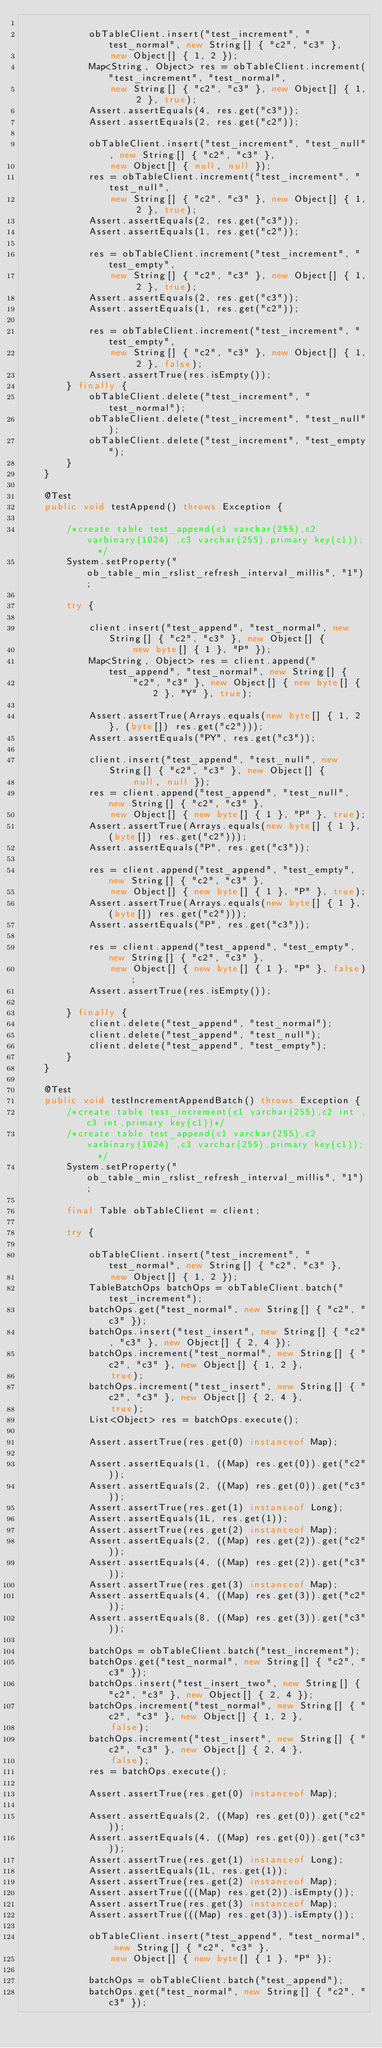Convert code to text. <code><loc_0><loc_0><loc_500><loc_500><_Java_>
            obTableClient.insert("test_increment", "test_normal", new String[] { "c2", "c3" },
                new Object[] { 1, 2 });
            Map<String, Object> res = obTableClient.increment("test_increment", "test_normal",
                new String[] { "c2", "c3" }, new Object[] { 1, 2 }, true);
            Assert.assertEquals(4, res.get("c3"));
            Assert.assertEquals(2, res.get("c2"));

            obTableClient.insert("test_increment", "test_null", new String[] { "c2", "c3" },
                new Object[] { null, null });
            res = obTableClient.increment("test_increment", "test_null",
                new String[] { "c2", "c3" }, new Object[] { 1, 2 }, true);
            Assert.assertEquals(2, res.get("c3"));
            Assert.assertEquals(1, res.get("c2"));

            res = obTableClient.increment("test_increment", "test_empty",
                new String[] { "c2", "c3" }, new Object[] { 1, 2 }, true);
            Assert.assertEquals(2, res.get("c3"));
            Assert.assertEquals(1, res.get("c2"));

            res = obTableClient.increment("test_increment", "test_empty",
                new String[] { "c2", "c3" }, new Object[] { 1, 2 }, false);
            Assert.assertTrue(res.isEmpty());
        } finally {
            obTableClient.delete("test_increment", "test_normal");
            obTableClient.delete("test_increment", "test_null");
            obTableClient.delete("test_increment", "test_empty");
        }
    }

    @Test
    public void testAppend() throws Exception {

        /*create table test_append(c1 varchar(255),c2 varbinary(1024) ,c3 varchar(255),primary key(c1));  */
        System.setProperty("ob_table_min_rslist_refresh_interval_millis", "1");

        try {

            client.insert("test_append", "test_normal", new String[] { "c2", "c3" }, new Object[] {
                    new byte[] { 1 }, "P" });
            Map<String, Object> res = client.append("test_append", "test_normal", new String[] {
                    "c2", "c3" }, new Object[] { new byte[] { 2 }, "Y" }, true);

            Assert.assertTrue(Arrays.equals(new byte[] { 1, 2 }, (byte[]) res.get("c2")));
            Assert.assertEquals("PY", res.get("c3"));

            client.insert("test_append", "test_null", new String[] { "c2", "c3" }, new Object[] {
                    null, null });
            res = client.append("test_append", "test_null", new String[] { "c2", "c3" },
                new Object[] { new byte[] { 1 }, "P" }, true);
            Assert.assertTrue(Arrays.equals(new byte[] { 1 }, (byte[]) res.get("c2")));
            Assert.assertEquals("P", res.get("c3"));

            res = client.append("test_append", "test_empty", new String[] { "c2", "c3" },
                new Object[] { new byte[] { 1 }, "P" }, true);
            Assert.assertTrue(Arrays.equals(new byte[] { 1 }, (byte[]) res.get("c2")));
            Assert.assertEquals("P", res.get("c3"));

            res = client.append("test_append", "test_empty", new String[] { "c2", "c3" },
                new Object[] { new byte[] { 1 }, "P" }, false);
            Assert.assertTrue(res.isEmpty());

        } finally {
            client.delete("test_append", "test_normal");
            client.delete("test_append", "test_null");
            client.delete("test_append", "test_empty");
        }
    }

    @Test
    public void testIncrementAppendBatch() throws Exception {
        /*create table test_increment(c1 varchar(255),c2 int ,c3 int,primary key(c1))*/
        /*create table test_append(c1 varchar(255),c2 varbinary(1024) ,c3 varchar(255),primary key(c1));  */
        System.setProperty("ob_table_min_rslist_refresh_interval_millis", "1");

        final Table obTableClient = client;

        try {

            obTableClient.insert("test_increment", "test_normal", new String[] { "c2", "c3" },
                new Object[] { 1, 2 });
            TableBatchOps batchOps = obTableClient.batch("test_increment");
            batchOps.get("test_normal", new String[] { "c2", "c3" });
            batchOps.insert("test_insert", new String[] { "c2", "c3" }, new Object[] { 2, 4 });
            batchOps.increment("test_normal", new String[] { "c2", "c3" }, new Object[] { 1, 2 },
                true);
            batchOps.increment("test_insert", new String[] { "c2", "c3" }, new Object[] { 2, 4 },
                true);
            List<Object> res = batchOps.execute();

            Assert.assertTrue(res.get(0) instanceof Map);

            Assert.assertEquals(1, ((Map) res.get(0)).get("c2"));
            Assert.assertEquals(2, ((Map) res.get(0)).get("c3"));
            Assert.assertTrue(res.get(1) instanceof Long);
            Assert.assertEquals(1L, res.get(1));
            Assert.assertTrue(res.get(2) instanceof Map);
            Assert.assertEquals(2, ((Map) res.get(2)).get("c2"));
            Assert.assertEquals(4, ((Map) res.get(2)).get("c3"));
            Assert.assertTrue(res.get(3) instanceof Map);
            Assert.assertEquals(4, ((Map) res.get(3)).get("c2"));
            Assert.assertEquals(8, ((Map) res.get(3)).get("c3"));

            batchOps = obTableClient.batch("test_increment");
            batchOps.get("test_normal", new String[] { "c2", "c3" });
            batchOps.insert("test_insert_two", new String[] { "c2", "c3" }, new Object[] { 2, 4 });
            batchOps.increment("test_normal", new String[] { "c2", "c3" }, new Object[] { 1, 2 },
                false);
            batchOps.increment("test_insert", new String[] { "c2", "c3" }, new Object[] { 2, 4 },
                false);
            res = batchOps.execute();

            Assert.assertTrue(res.get(0) instanceof Map);

            Assert.assertEquals(2, ((Map) res.get(0)).get("c2"));
            Assert.assertEquals(4, ((Map) res.get(0)).get("c3"));
            Assert.assertTrue(res.get(1) instanceof Long);
            Assert.assertEquals(1L, res.get(1));
            Assert.assertTrue(res.get(2) instanceof Map);
            Assert.assertTrue(((Map) res.get(2)).isEmpty());
            Assert.assertTrue(res.get(3) instanceof Map);
            Assert.assertTrue(((Map) res.get(3)).isEmpty());

            obTableClient.insert("test_append", "test_normal", new String[] { "c2", "c3" },
                new Object[] { new byte[] { 1 }, "P" });

            batchOps = obTableClient.batch("test_append");
            batchOps.get("test_normal", new String[] { "c2", "c3" });</code> 